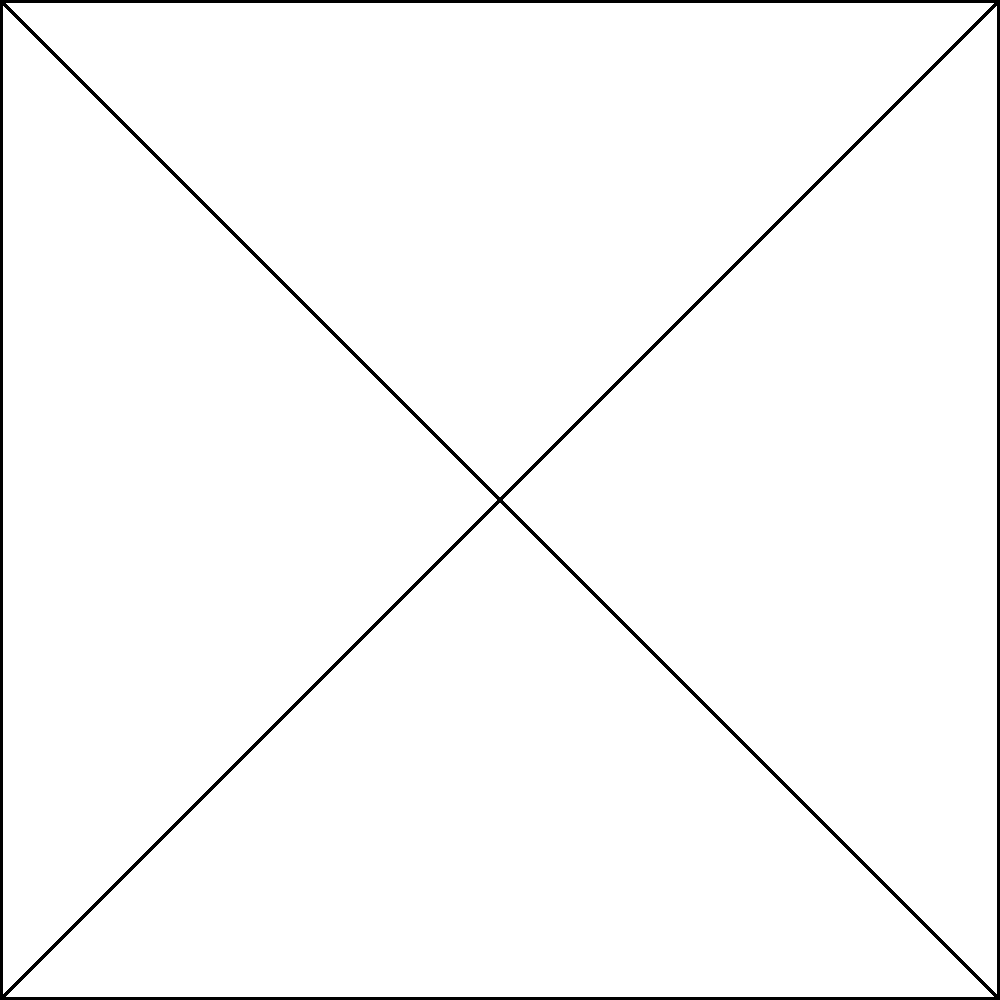In the theoretical layout of an antigravity device blueprint shown above, which component is most likely responsible for counteracting the effects of gravity directly? To answer this question, we need to analyze the components of the theoretical antigravity device:

1. The device is shown as a square with diagonal lines and a circle in the center.
2. There are five labeled components:
   a) Core (center)
   b) Gravity Nullifier
   c) EM Field Generator
   d) Power Source
   e) Control Unit

3. The question asks about counteracting gravity directly.

4. Among these components, the "Gravity Nullifier" is the most likely candidate for this function:
   - Its name directly implies a role in negating or canceling gravity.
   - Other components have more general or supporting functions:
     * The Core is likely the central element but not specifically for gravity manipulation.
     * The EM Field Generator might create electromagnetic fields, which could indirectly affect gravity but not directly counteract it.
     * The Power Source provides energy to the system.
     * The Control Unit likely manages the overall operation.

5. The Gravity Nullifier, by its name and implied function, is the component most directly associated with counteracting gravity.

Therefore, the Gravity Nullifier is the most logical answer to this question.
Answer: Gravity Nullifier 